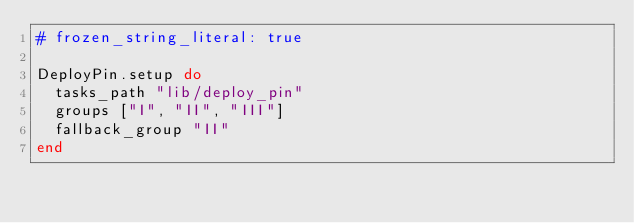Convert code to text. <code><loc_0><loc_0><loc_500><loc_500><_Ruby_># frozen_string_literal: true

DeployPin.setup do
  tasks_path "lib/deploy_pin"
  groups ["I", "II", "III"]
  fallback_group "II"
end
</code> 